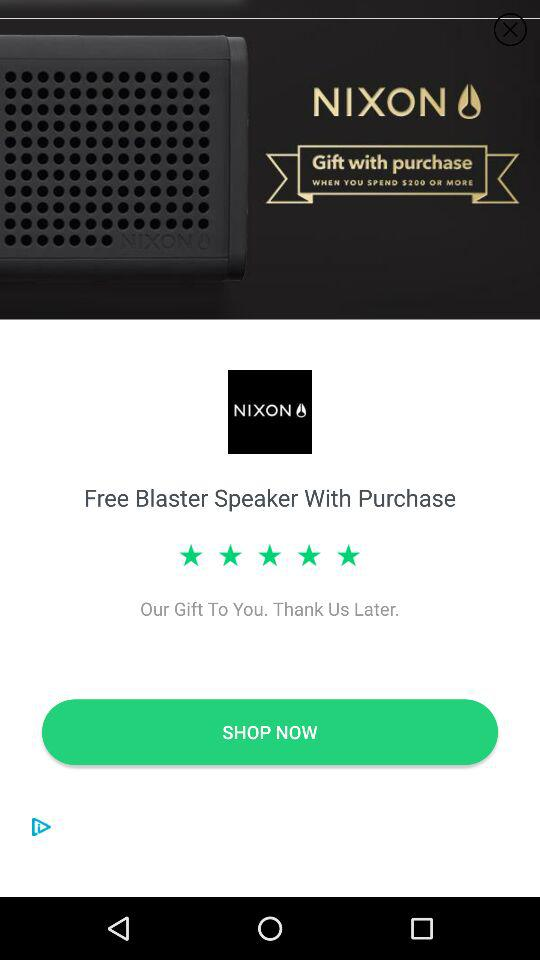What is the rating? The rating is 5 stars. 